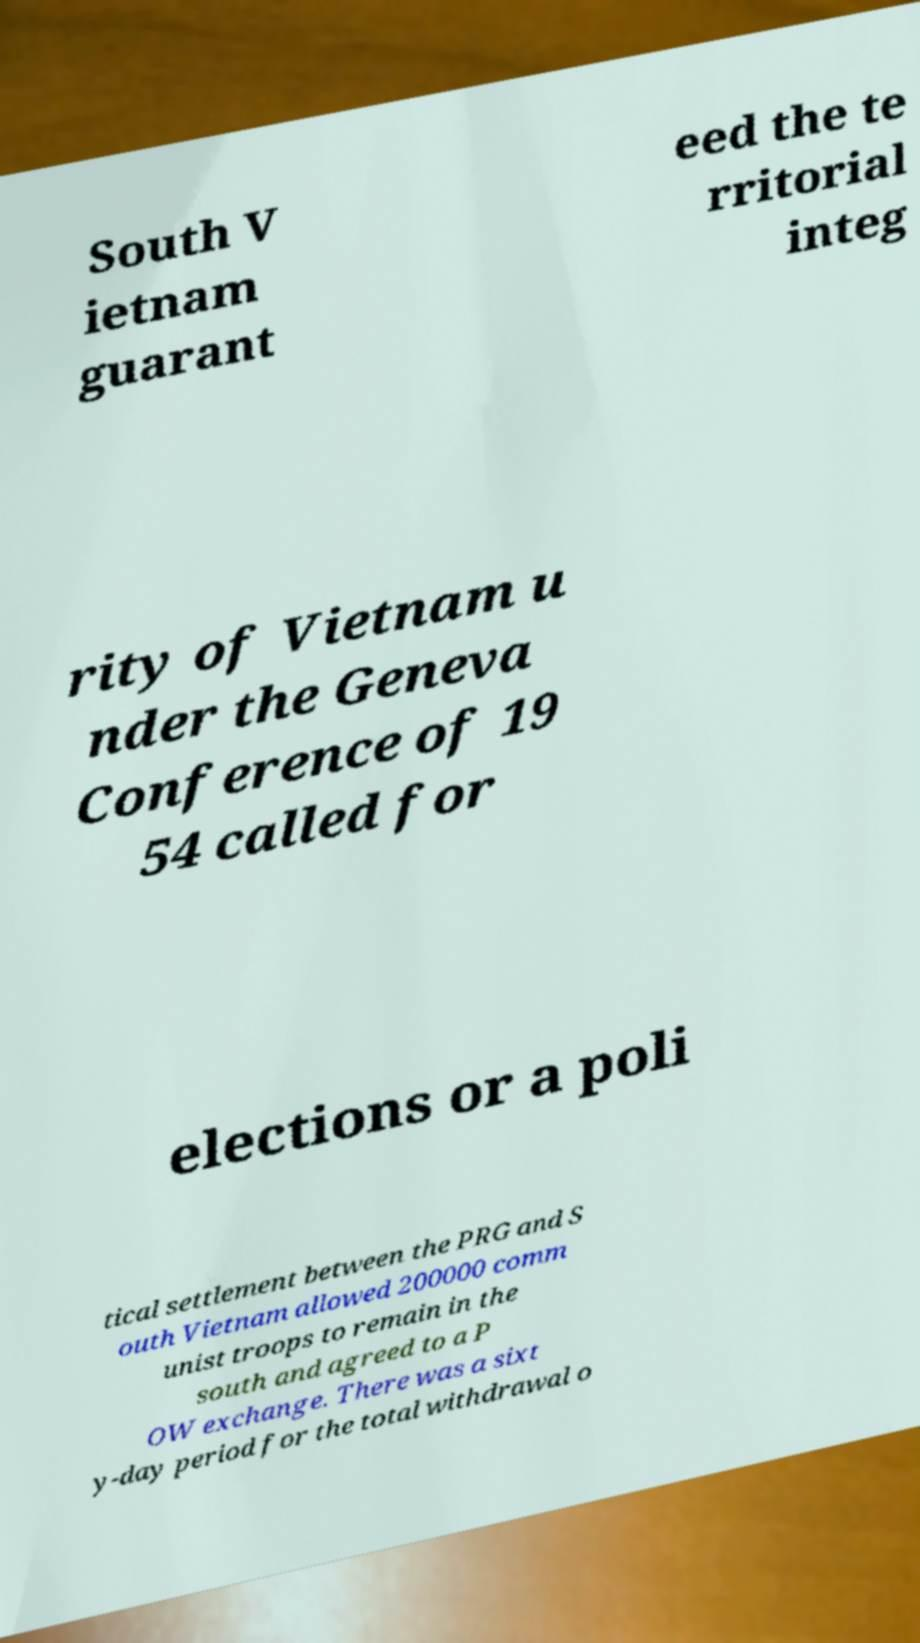Please identify and transcribe the text found in this image. South V ietnam guarant eed the te rritorial integ rity of Vietnam u nder the Geneva Conference of 19 54 called for elections or a poli tical settlement between the PRG and S outh Vietnam allowed 200000 comm unist troops to remain in the south and agreed to a P OW exchange. There was a sixt y-day period for the total withdrawal o 